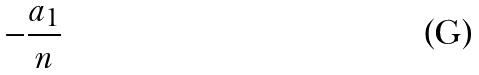Convert formula to latex. <formula><loc_0><loc_0><loc_500><loc_500>- \frac { a _ { 1 } } { n }</formula> 